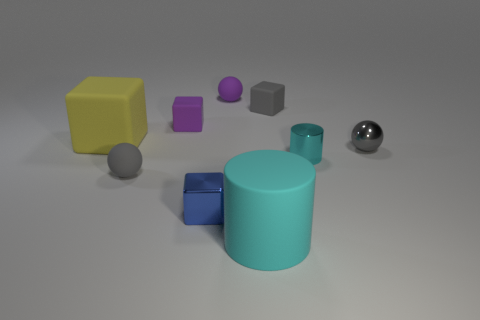How many other objects are the same color as the small cylinder?
Offer a terse response. 1. Are there an equal number of shiny cylinders that are in front of the blue thing and large cyan objects?
Keep it short and to the point. No. There is a small sphere in front of the cyan cylinder that is to the right of the cyan rubber cylinder; how many gray objects are on the right side of it?
Give a very brief answer. 2. Is the size of the blue cube the same as the cyan cylinder that is on the right side of the gray rubber block?
Provide a succinct answer. Yes. How many big things are there?
Ensure brevity in your answer.  2. Do the matte ball behind the metal ball and the matte block that is to the right of the blue thing have the same size?
Your response must be concise. Yes. What is the color of the tiny shiny object that is the same shape as the large cyan object?
Give a very brief answer. Cyan. Is the shape of the blue object the same as the large yellow object?
Offer a very short reply. Yes. There is a purple rubber thing that is the same shape as the tiny blue metal thing; what is its size?
Offer a terse response. Small. What number of tiny cyan things have the same material as the large block?
Offer a terse response. 0. 